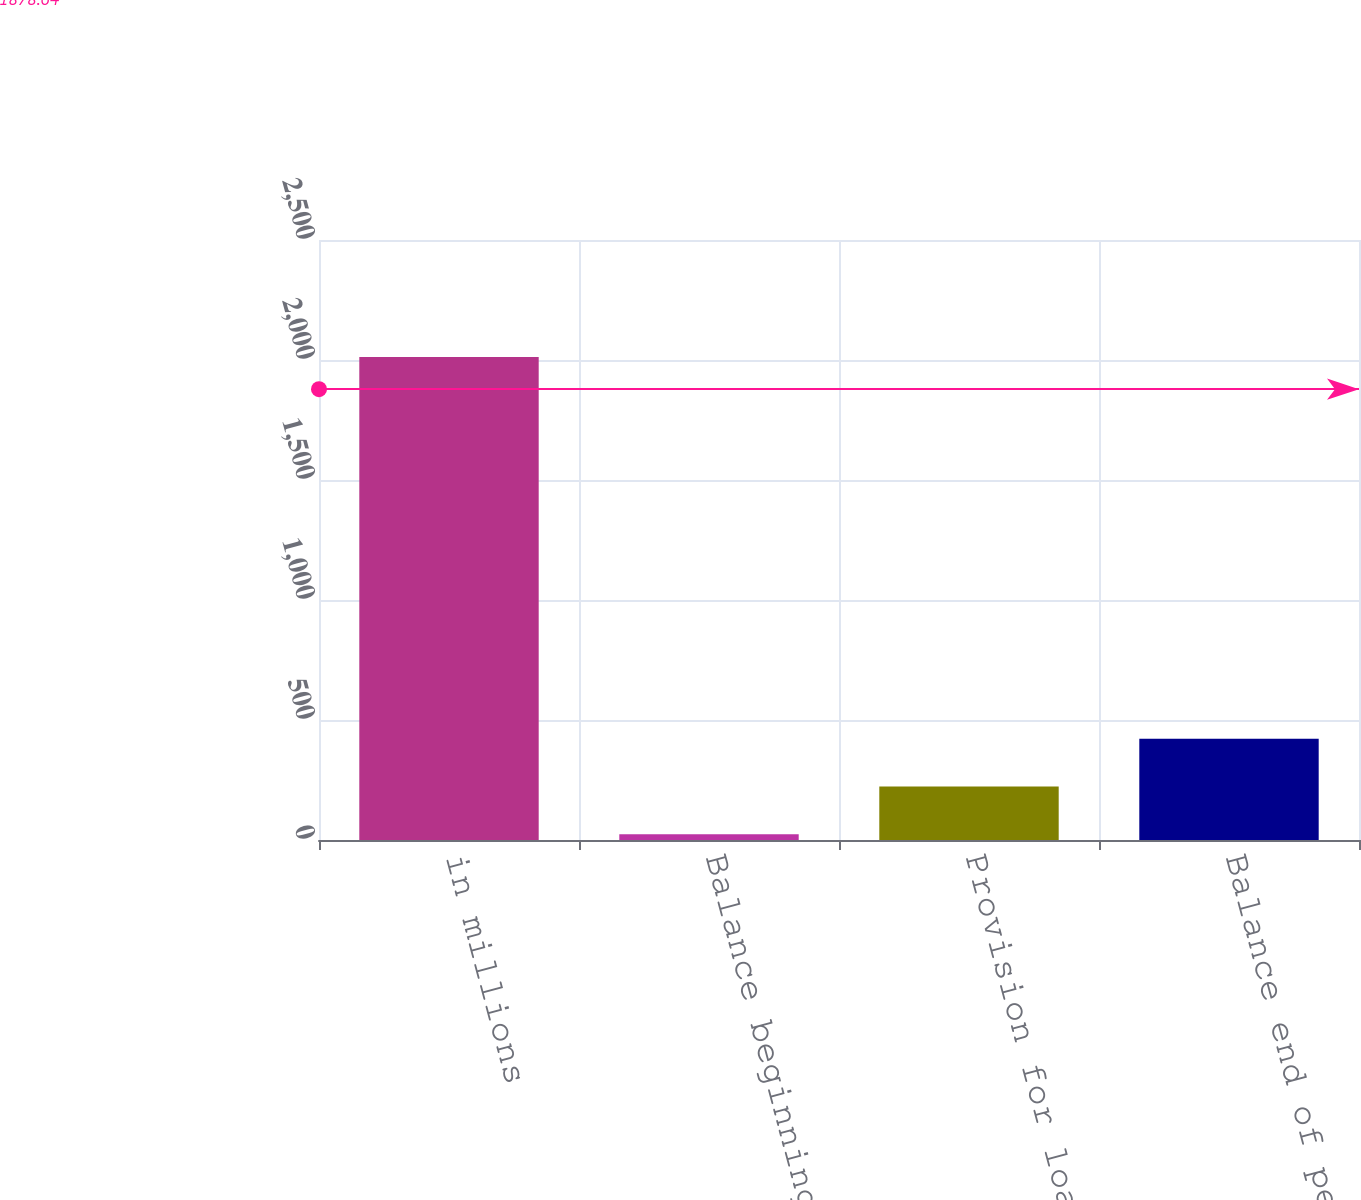Convert chart to OTSL. <chart><loc_0><loc_0><loc_500><loc_500><bar_chart><fcel>in millions<fcel>Balance beginning of period<fcel>Provision for loan losses<fcel>Balance end of period<nl><fcel>2013<fcel>24<fcel>222.9<fcel>421.8<nl></chart> 